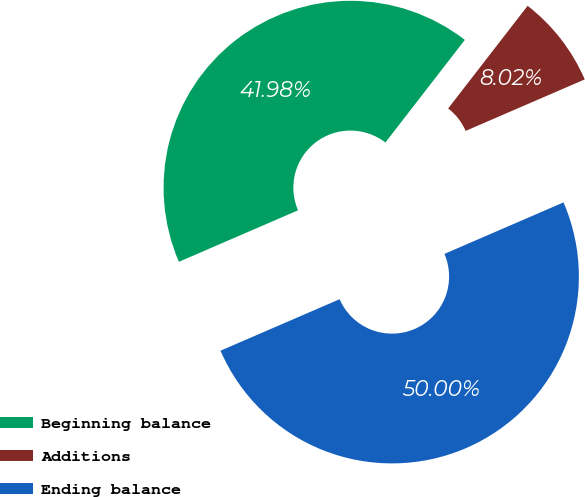<chart> <loc_0><loc_0><loc_500><loc_500><pie_chart><fcel>Beginning balance<fcel>Additions<fcel>Ending balance<nl><fcel>41.98%<fcel>8.02%<fcel>50.0%<nl></chart> 